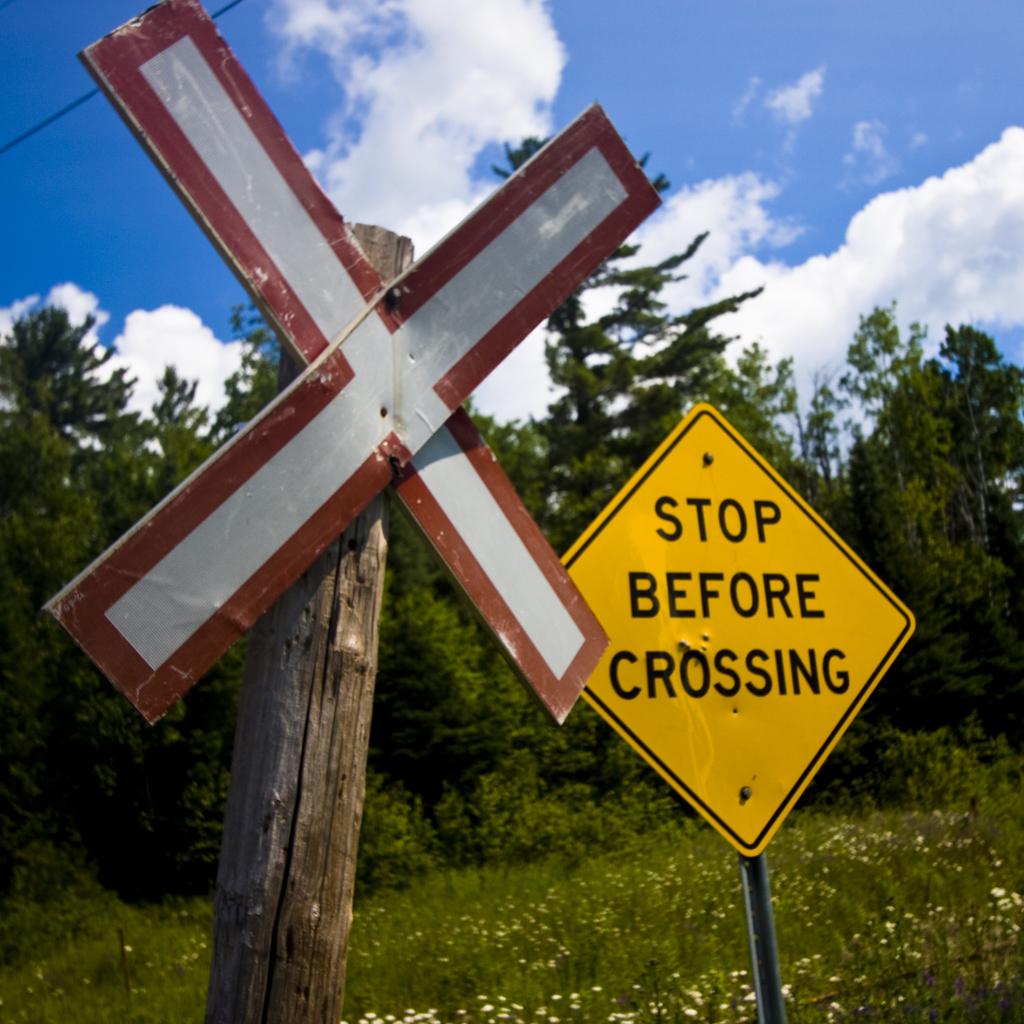What does the sign say?
Provide a short and direct response. Stop before crossing. What should you do before crossing according to the sign?
Provide a short and direct response. Stop. 